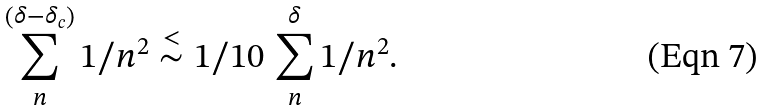<formula> <loc_0><loc_0><loc_500><loc_500>\sum _ { n } ^ { \left ( \delta - \delta _ { c } \right ) } 1 / n ^ { 2 } \stackrel { < } { \sim } 1 / 1 0 \, \sum _ { n } ^ { \delta } 1 / n ^ { 2 } .</formula> 